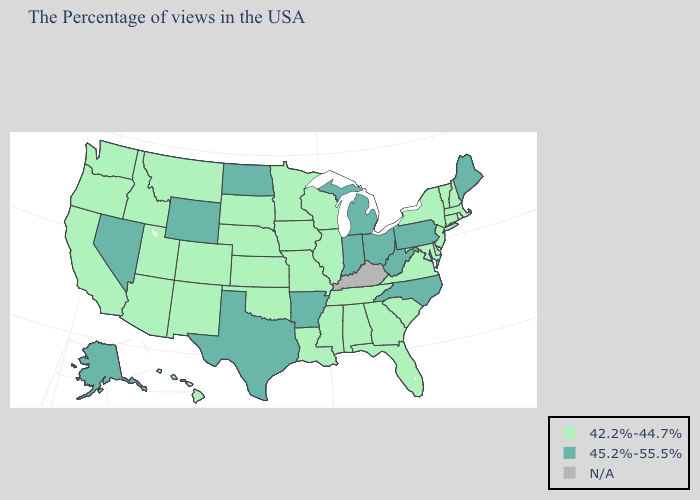Which states have the highest value in the USA?
Short answer required. Maine, Pennsylvania, North Carolina, West Virginia, Ohio, Michigan, Indiana, Arkansas, Texas, North Dakota, Wyoming, Nevada, Alaska. What is the value of Wisconsin?
Quick response, please. 42.2%-44.7%. Name the states that have a value in the range 45.2%-55.5%?
Answer briefly. Maine, Pennsylvania, North Carolina, West Virginia, Ohio, Michigan, Indiana, Arkansas, Texas, North Dakota, Wyoming, Nevada, Alaska. Among the states that border New Jersey , does Delaware have the highest value?
Give a very brief answer. No. What is the value of Oregon?
Answer briefly. 42.2%-44.7%. What is the value of Delaware?
Short answer required. 42.2%-44.7%. Which states have the highest value in the USA?
Be succinct. Maine, Pennsylvania, North Carolina, West Virginia, Ohio, Michigan, Indiana, Arkansas, Texas, North Dakota, Wyoming, Nevada, Alaska. What is the value of Vermont?
Keep it brief. 42.2%-44.7%. What is the value of Nebraska?
Quick response, please. 42.2%-44.7%. Does New York have the highest value in the Northeast?
Write a very short answer. No. Does Arizona have the lowest value in the USA?
Keep it brief. Yes. What is the lowest value in states that border Vermont?
Quick response, please. 42.2%-44.7%. Among the states that border New Jersey , does New York have the highest value?
Write a very short answer. No. 